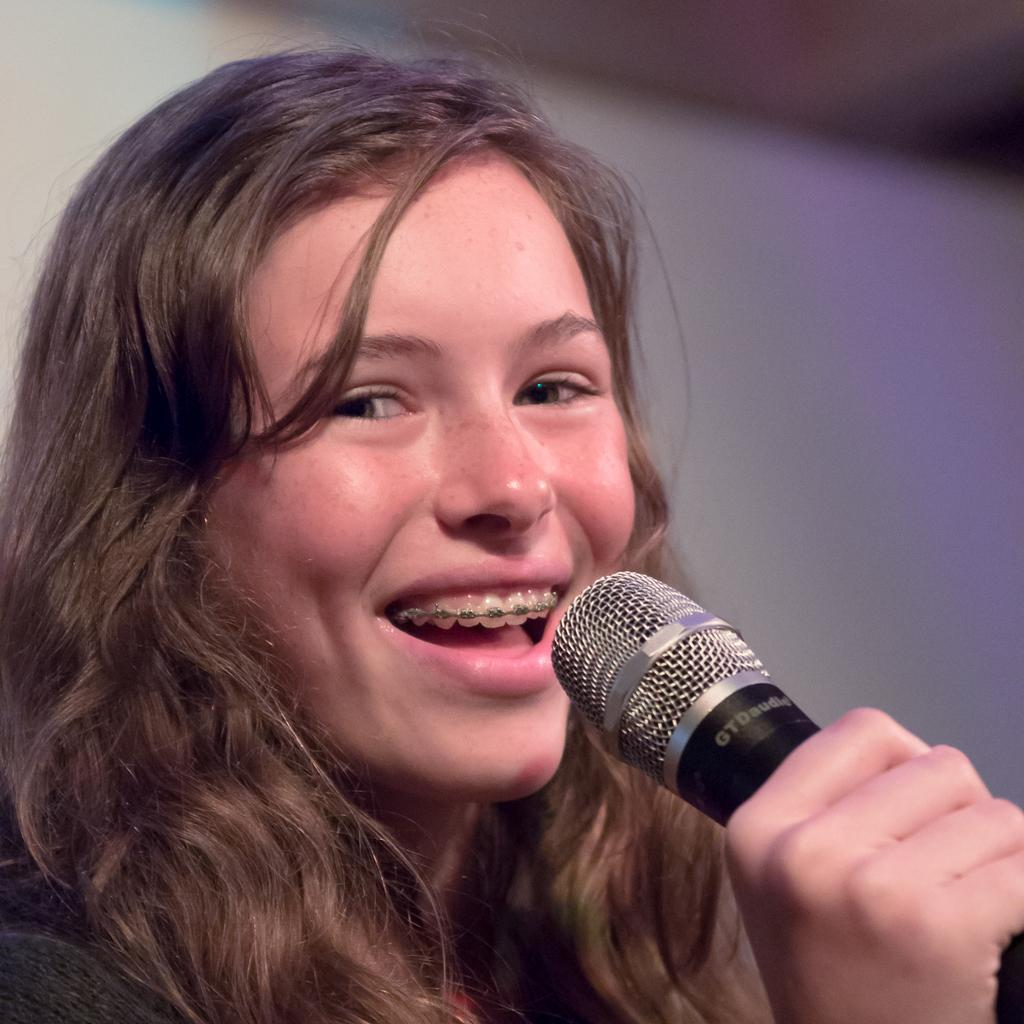Who is the main subject in the image? There is a woman in the image. What is the woman doing in the image? The woman is talking into a microphone. How does the woman appear to be feeling in the image? The woman is smiling, which suggests she is happy or enjoying herself. What type of jewel can be seen on the woman's forehead in the image? There is no jewel visible on the woman's forehead in the image. Is the woman using a pipe to communicate through the microphone? No, the woman is not using a pipe to communicate through the microphone; she is talking directly into the microphone. 